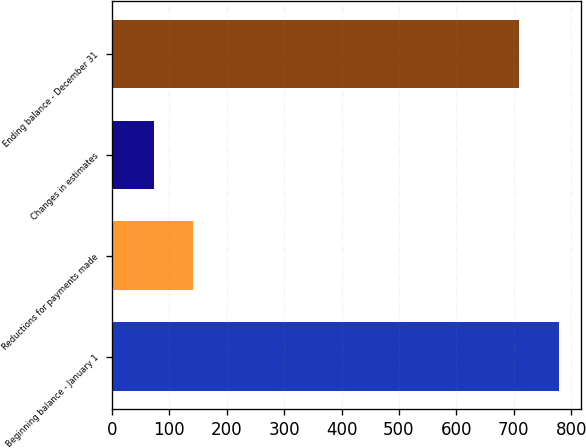Convert chart to OTSL. <chart><loc_0><loc_0><loc_500><loc_500><bar_chart><fcel>Beginning balance - January 1<fcel>Reductions for payments made<fcel>Changes in estimates<fcel>Ending balance - December 31<nl><fcel>778.5<fcel>141.5<fcel>73<fcel>710<nl></chart> 